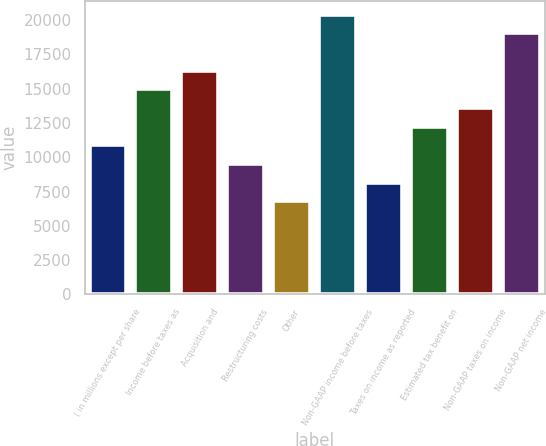Convert chart. <chart><loc_0><loc_0><loc_500><loc_500><bar_chart><fcel>( in millions except per share<fcel>Income before taxes as<fcel>Acquisition and<fcel>Restructuring costs<fcel>Other<fcel>Non-GAAP income before taxes<fcel>Taxes on income as reported<fcel>Estimated tax benefit on<fcel>Non-GAAP taxes on income<fcel>Non-GAAP net income<nl><fcel>10878.7<fcel>14957.7<fcel>16317.3<fcel>9519.03<fcel>6799.71<fcel>20396.3<fcel>8159.37<fcel>12238.4<fcel>13598<fcel>19036.7<nl></chart> 